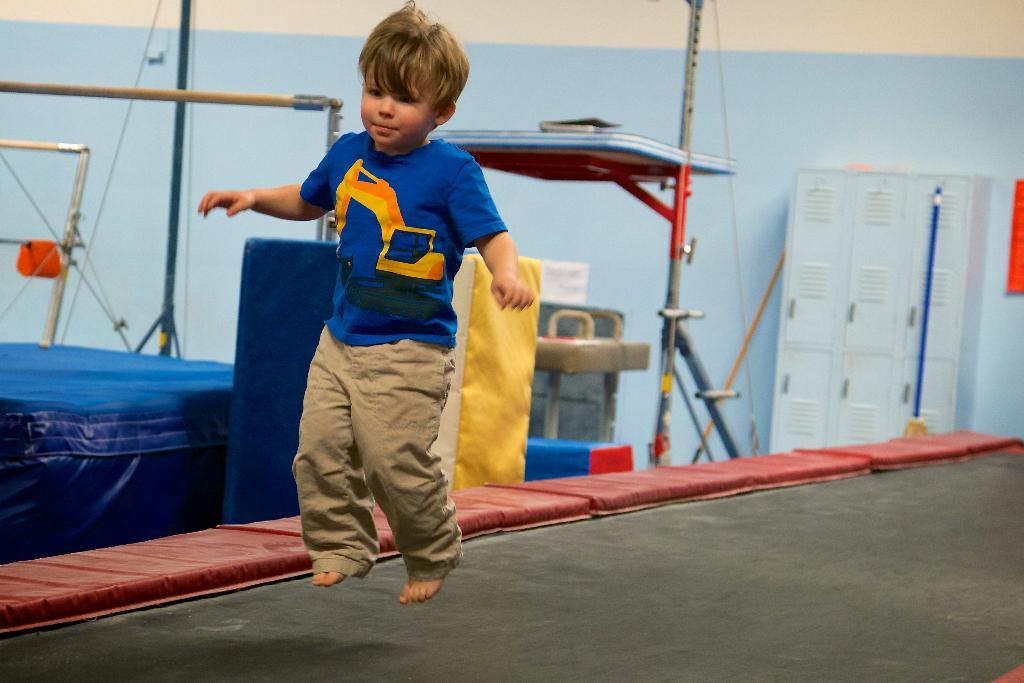What is the main subject of the image? There is a boy in the air in the center of the image. What can be seen in the background of the image? In the background, there are cupboards, poles, wires, and a wall. What type of guitar is the boy playing in the image? There is no guitar present in the image; the boy is simply in the air. Can you see any bones in the image? There are no bones visible in the image. 